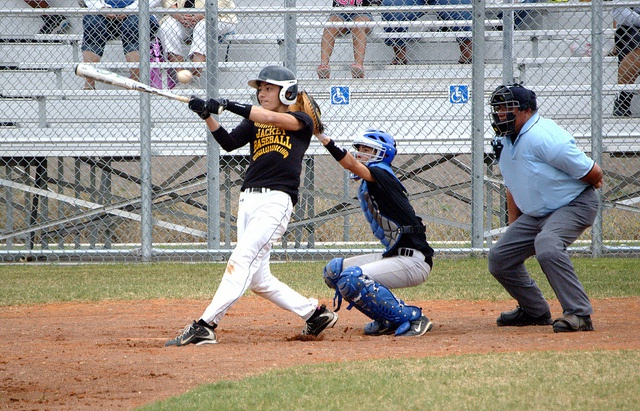Describe the objects in this image and their specific colors. I can see people in darkgray, black, and gray tones, people in darkgray, white, black, and gray tones, people in darkgray, black, lavender, and navy tones, people in darkgray, lightgray, and gray tones, and people in darkgray, gray, black, and white tones in this image. 